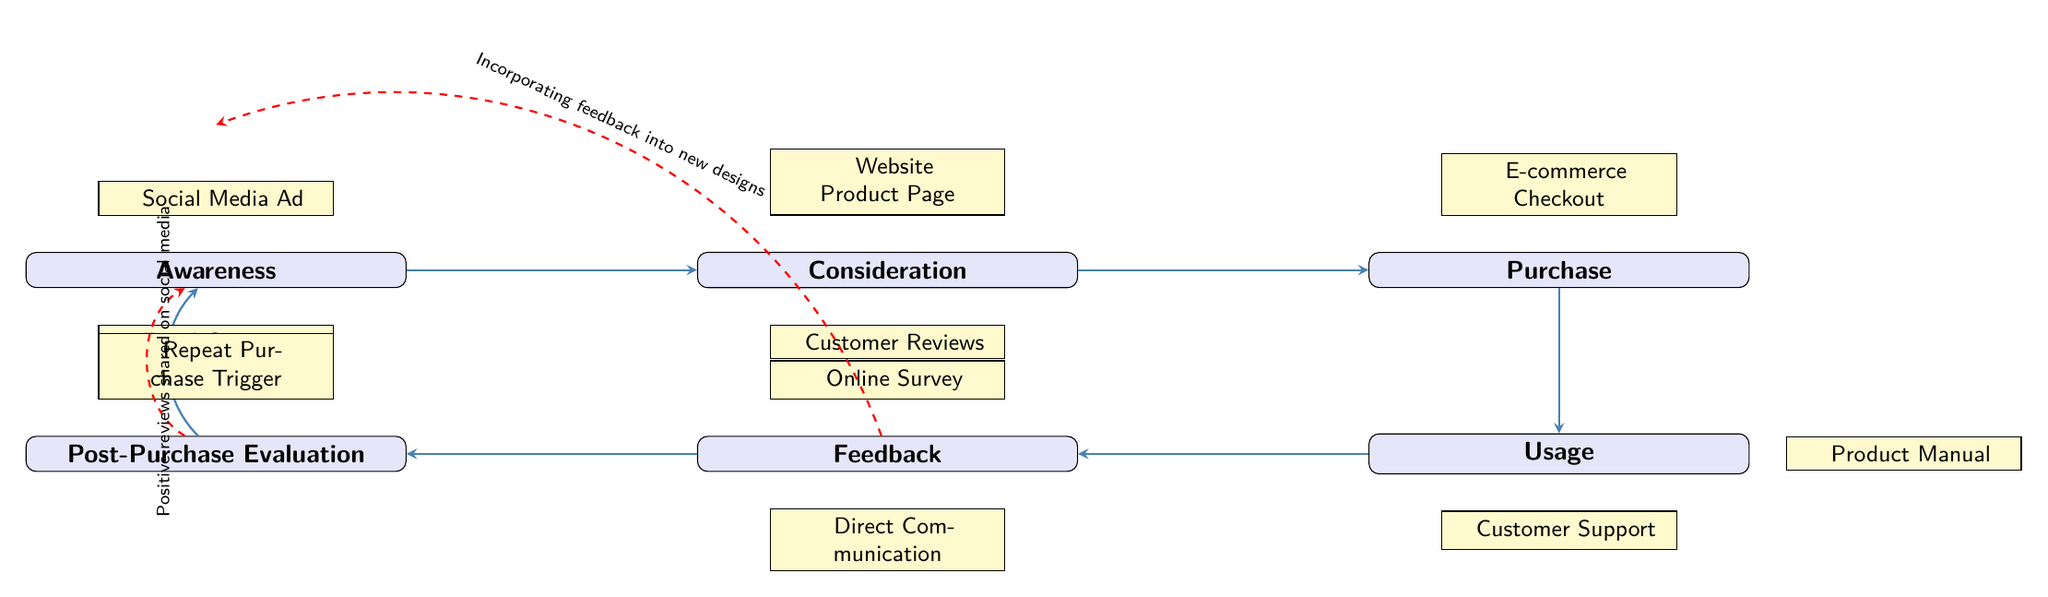What is the first stage in the customer journey? The diagram lists "Awareness" as the initial stage of the customer journey, represented as the first node on the flow from left to right.
Answer: Awareness How many touchpoints are associated with the purchase stage? The diagram displays only one touchpoint for the purchase stage, specifically "E-commerce Checkout" positioned directly above this stage.
Answer: One What is the last stage in the customer journey? The last stage shown in the diagram is "Post-Purchase Evaluation," which is located on the left side, below "Feedback" and before the loop back to "Awareness."
Answer: Post-Purchase Evaluation Which touchpoint is linked to the consideration stage? The diagram indicates two touchpoints for the consideration stage: "Website Product Page" above and "Customer Reviews" below, showing interaction at this stage.
Answer: Website Product Page and Customer Reviews What feedback loop incorporates customer feedback? The diagram illustrates a feedback loop from "Feedback" back to "Awareness," indicating how customer feedback is utilized to influence the awareness stage and improve designs.
Answer: Incorporating feedback into new designs What touchpoint is directly connected to the usage stage? The diagram includes two touchpoints for the usage stage: "Product Manual" on the right and "Customer Support" below, suggesting assistance and information during the usage phase.
Answer: Product Manual and Customer Support How many total stages are depicted in the customer journey? The diagram features a total of six distinct stages represented by nodes, each marking a significant point in the customer journey from awareness to evaluation.
Answer: Six Which touchpoint indicates a trigger for repeat purchase? The touchpoint "Repeat Purchase Trigger" is specifically indicated above the "Post-Purchase Evaluation" stage, suggesting how the evaluation process can lead to additional purchases.
Answer: Repeat Purchase Trigger 